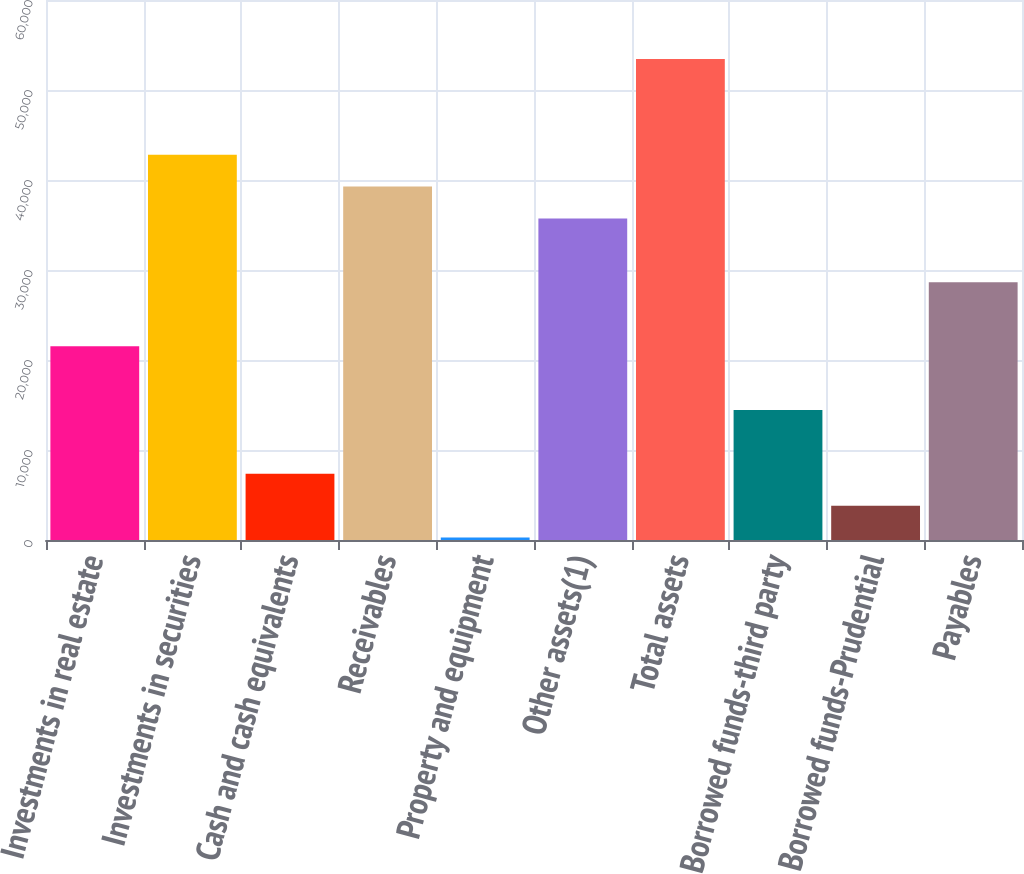Convert chart to OTSL. <chart><loc_0><loc_0><loc_500><loc_500><bar_chart><fcel>Investments in real estate<fcel>Investments in securities<fcel>Cash and cash equivalents<fcel>Receivables<fcel>Property and equipment<fcel>Other assets(1)<fcel>Total assets<fcel>Borrowed funds-third party<fcel>Borrowed funds-Prudential<fcel>Payables<nl><fcel>21538<fcel>42811<fcel>7356<fcel>39265.5<fcel>265<fcel>35720<fcel>53447.5<fcel>14447<fcel>3810.5<fcel>28629<nl></chart> 